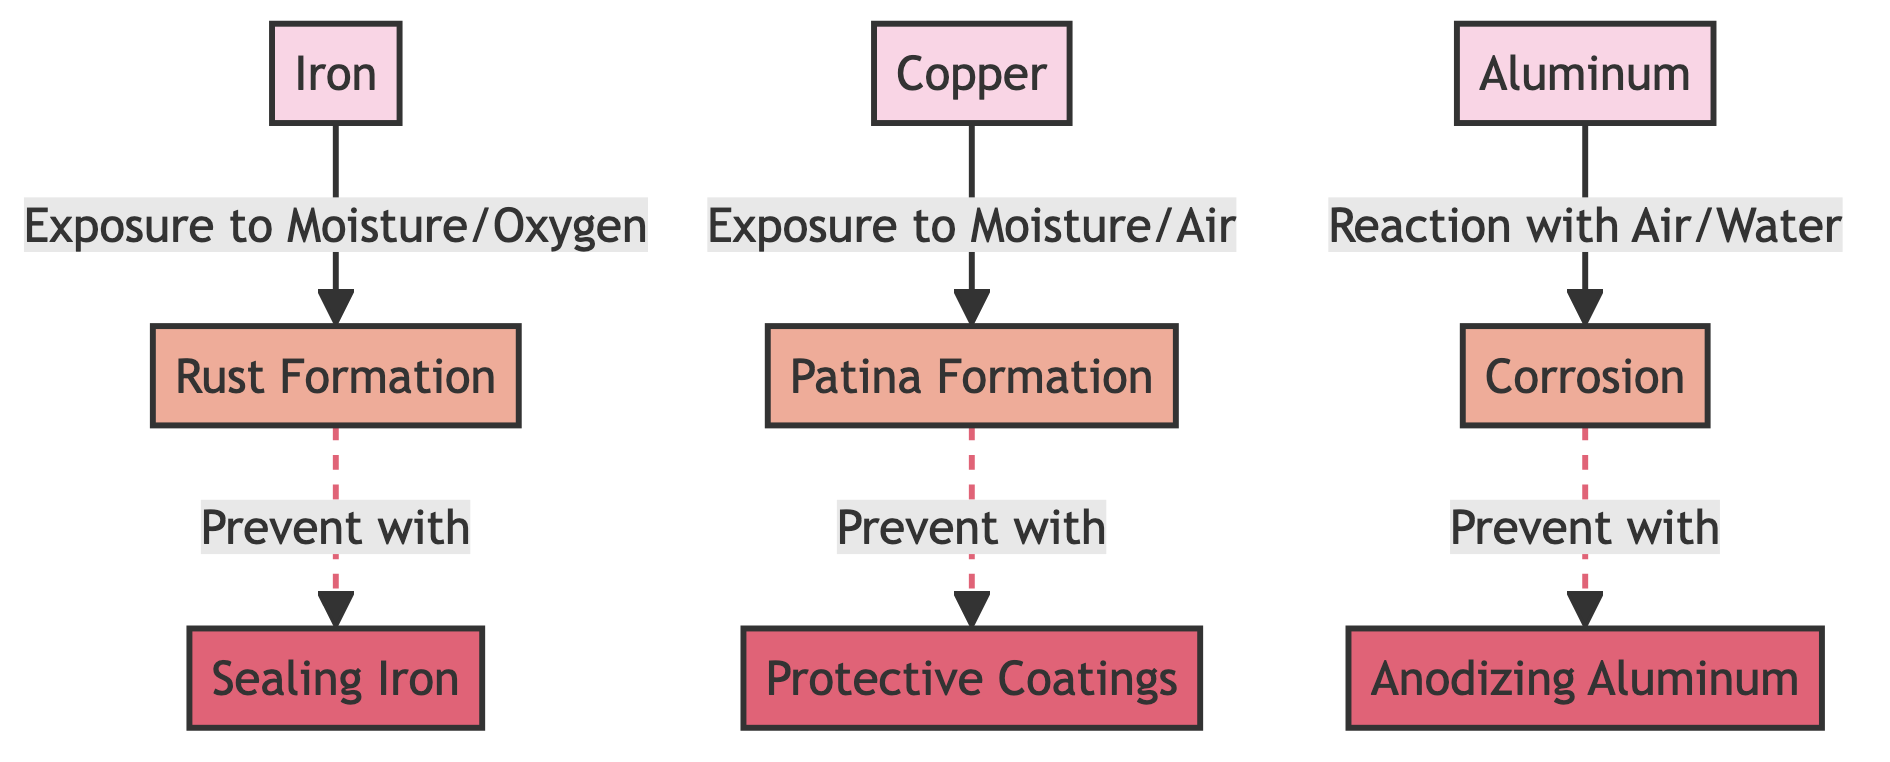What metals are listed in the diagram? The diagram includes three metals: Iron, Copper, and Aluminum.
Answer: Iron, Copper, Aluminum How many prevention strategies are shown in the diagram? There are three prevention strategies corresponding to each metal: sealing iron, protective coatings for copper, and anodizing aluminum.
Answer: 3 What process is associated with Copper? The process associated with Copper is Patina Formation.
Answer: Patina Formation Which metal undergoes Rust Formation? Iron undergoes Rust Formation as indicated by the direct relationship in the diagram.
Answer: Iron What type of exposure leads to Corrosion in Aluminum? Corrosion in Aluminum is caused by a Reaction with Air/Water, as indicated in the diagram.
Answer: Reaction with Air/Water What is the prevention method for Rust Formation? The prevention method for Rust Formation is Sealing Iron.
Answer: Sealing Iron How many relationships lead to the processes shown in the diagram? There are three relationships leading to the processes: one for Rust Formation, one for Patina Formation, and one for Corrosion.
Answer: 3 What visual indication identifies the prevention strategies in the diagram? The prevention strategies are visually indicated in a specific color (pink) and identified as separate nodes connected to each process through dashed lines.
Answer: Pink Which prevention strategy corresponds to Copper? The prevention strategy for Copper is Protective Coatings.
Answer: Protective Coatings 